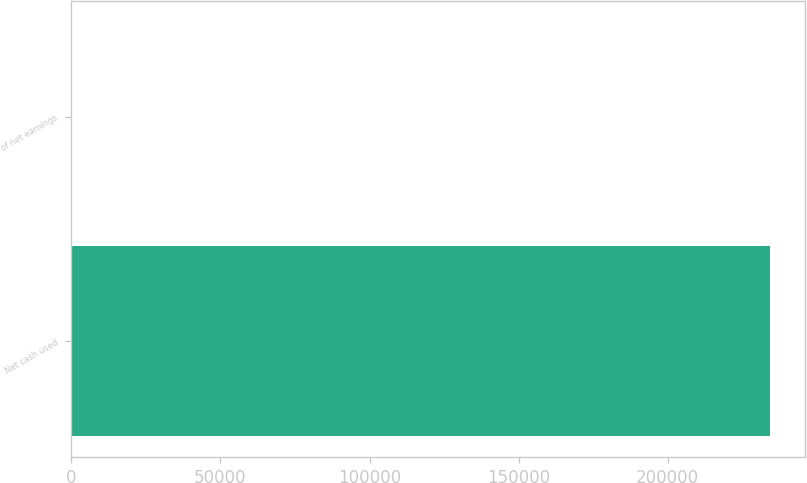<chart> <loc_0><loc_0><loc_500><loc_500><bar_chart><fcel>Net cash used<fcel>of net earnings<nl><fcel>234443<fcel>52.3<nl></chart> 